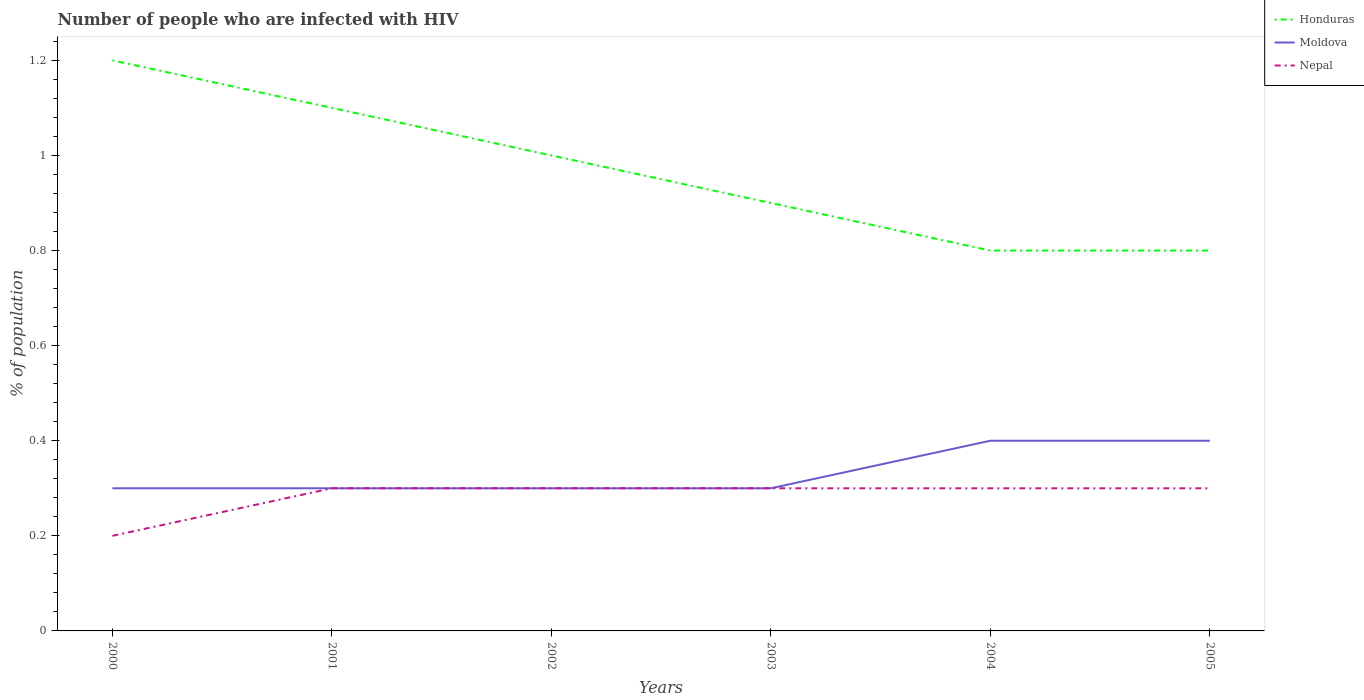How many different coloured lines are there?
Offer a very short reply. 3. Is the number of lines equal to the number of legend labels?
Provide a short and direct response. Yes. Across all years, what is the maximum percentage of HIV infected population in in Moldova?
Make the answer very short. 0.3. In which year was the percentage of HIV infected population in in Moldova maximum?
Your answer should be very brief. 2000. What is the total percentage of HIV infected population in in Moldova in the graph?
Your answer should be compact. -0.1. What is the difference between the highest and the second highest percentage of HIV infected population in in Honduras?
Offer a terse response. 0.4. Is the percentage of HIV infected population in in Honduras strictly greater than the percentage of HIV infected population in in Nepal over the years?
Make the answer very short. No. How many lines are there?
Your answer should be compact. 3. What is the difference between two consecutive major ticks on the Y-axis?
Keep it short and to the point. 0.2. Does the graph contain any zero values?
Your answer should be compact. No. Does the graph contain grids?
Ensure brevity in your answer.  No. Where does the legend appear in the graph?
Your response must be concise. Top right. How many legend labels are there?
Make the answer very short. 3. How are the legend labels stacked?
Your answer should be compact. Vertical. What is the title of the graph?
Keep it short and to the point. Number of people who are infected with HIV. Does "Serbia" appear as one of the legend labels in the graph?
Provide a succinct answer. No. What is the label or title of the Y-axis?
Ensure brevity in your answer.  % of population. What is the % of population of Honduras in 2000?
Make the answer very short. 1.2. What is the % of population in Nepal in 2001?
Keep it short and to the point. 0.3. What is the % of population in Honduras in 2002?
Your answer should be compact. 1. What is the % of population in Moldova in 2002?
Keep it short and to the point. 0.3. What is the % of population in Nepal in 2002?
Offer a terse response. 0.3. What is the % of population of Nepal in 2003?
Offer a terse response. 0.3. What is the % of population of Honduras in 2004?
Give a very brief answer. 0.8. What is the % of population of Nepal in 2004?
Keep it short and to the point. 0.3. What is the % of population of Nepal in 2005?
Ensure brevity in your answer.  0.3. Across all years, what is the maximum % of population of Nepal?
Provide a short and direct response. 0.3. Across all years, what is the minimum % of population in Honduras?
Provide a succinct answer. 0.8. Across all years, what is the minimum % of population of Moldova?
Offer a very short reply. 0.3. What is the total % of population of Honduras in the graph?
Provide a succinct answer. 5.8. What is the total % of population in Nepal in the graph?
Keep it short and to the point. 1.7. What is the difference between the % of population of Honduras in 2000 and that in 2001?
Provide a short and direct response. 0.1. What is the difference between the % of population of Moldova in 2000 and that in 2001?
Keep it short and to the point. 0. What is the difference between the % of population in Nepal in 2000 and that in 2001?
Your answer should be compact. -0.1. What is the difference between the % of population of Moldova in 2000 and that in 2002?
Provide a succinct answer. 0. What is the difference between the % of population of Honduras in 2000 and that in 2003?
Give a very brief answer. 0.3. What is the difference between the % of population in Honduras in 2000 and that in 2004?
Your answer should be very brief. 0.4. What is the difference between the % of population of Nepal in 2000 and that in 2004?
Your response must be concise. -0.1. What is the difference between the % of population in Moldova in 2001 and that in 2002?
Ensure brevity in your answer.  0. What is the difference between the % of population in Nepal in 2001 and that in 2003?
Keep it short and to the point. 0. What is the difference between the % of population in Moldova in 2001 and that in 2004?
Give a very brief answer. -0.1. What is the difference between the % of population in Honduras in 2001 and that in 2005?
Your response must be concise. 0.3. What is the difference between the % of population of Moldova in 2001 and that in 2005?
Give a very brief answer. -0.1. What is the difference between the % of population of Honduras in 2002 and that in 2003?
Keep it short and to the point. 0.1. What is the difference between the % of population of Honduras in 2002 and that in 2004?
Make the answer very short. 0.2. What is the difference between the % of population of Moldova in 2002 and that in 2004?
Offer a terse response. -0.1. What is the difference between the % of population of Moldova in 2002 and that in 2005?
Your answer should be compact. -0.1. What is the difference between the % of population in Nepal in 2002 and that in 2005?
Provide a short and direct response. 0. What is the difference between the % of population of Honduras in 2003 and that in 2004?
Your answer should be compact. 0.1. What is the difference between the % of population of Honduras in 2003 and that in 2005?
Provide a short and direct response. 0.1. What is the difference between the % of population in Moldova in 2003 and that in 2005?
Your response must be concise. -0.1. What is the difference between the % of population of Nepal in 2003 and that in 2005?
Keep it short and to the point. 0. What is the difference between the % of population of Honduras in 2004 and that in 2005?
Make the answer very short. 0. What is the difference between the % of population in Moldova in 2004 and that in 2005?
Offer a very short reply. 0. What is the difference between the % of population of Nepal in 2004 and that in 2005?
Ensure brevity in your answer.  0. What is the difference between the % of population in Honduras in 2000 and the % of population in Moldova in 2001?
Your answer should be compact. 0.9. What is the difference between the % of population in Honduras in 2000 and the % of population in Nepal in 2001?
Your response must be concise. 0.9. What is the difference between the % of population in Moldova in 2000 and the % of population in Nepal in 2001?
Your answer should be very brief. 0. What is the difference between the % of population of Honduras in 2000 and the % of population of Nepal in 2002?
Your answer should be compact. 0.9. What is the difference between the % of population of Moldova in 2000 and the % of population of Nepal in 2002?
Make the answer very short. 0. What is the difference between the % of population of Moldova in 2000 and the % of population of Nepal in 2003?
Provide a short and direct response. 0. What is the difference between the % of population in Honduras in 2000 and the % of population in Moldova in 2004?
Your response must be concise. 0.8. What is the difference between the % of population of Moldova in 2000 and the % of population of Nepal in 2004?
Give a very brief answer. 0. What is the difference between the % of population of Honduras in 2000 and the % of population of Moldova in 2005?
Offer a terse response. 0.8. What is the difference between the % of population of Moldova in 2000 and the % of population of Nepal in 2005?
Offer a very short reply. 0. What is the difference between the % of population of Honduras in 2001 and the % of population of Nepal in 2002?
Give a very brief answer. 0.8. What is the difference between the % of population in Honduras in 2001 and the % of population in Moldova in 2003?
Give a very brief answer. 0.8. What is the difference between the % of population of Honduras in 2001 and the % of population of Nepal in 2003?
Give a very brief answer. 0.8. What is the difference between the % of population of Moldova in 2001 and the % of population of Nepal in 2003?
Provide a short and direct response. 0. What is the difference between the % of population of Honduras in 2001 and the % of population of Moldova in 2004?
Make the answer very short. 0.7. What is the difference between the % of population in Honduras in 2001 and the % of population in Moldova in 2005?
Your response must be concise. 0.7. What is the difference between the % of population of Honduras in 2001 and the % of population of Nepal in 2005?
Your answer should be compact. 0.8. What is the difference between the % of population in Moldova in 2001 and the % of population in Nepal in 2005?
Ensure brevity in your answer.  0. What is the difference between the % of population of Moldova in 2002 and the % of population of Nepal in 2003?
Provide a short and direct response. 0. What is the difference between the % of population in Honduras in 2002 and the % of population in Nepal in 2004?
Provide a succinct answer. 0.7. What is the difference between the % of population in Moldova in 2002 and the % of population in Nepal in 2004?
Keep it short and to the point. 0. What is the difference between the % of population in Moldova in 2002 and the % of population in Nepal in 2005?
Make the answer very short. 0. What is the difference between the % of population of Honduras in 2003 and the % of population of Nepal in 2004?
Provide a short and direct response. 0.6. What is the difference between the % of population in Moldova in 2003 and the % of population in Nepal in 2004?
Your answer should be very brief. 0. What is the difference between the % of population in Moldova in 2003 and the % of population in Nepal in 2005?
Offer a terse response. 0. What is the difference between the % of population of Honduras in 2004 and the % of population of Moldova in 2005?
Your answer should be compact. 0.4. What is the difference between the % of population in Moldova in 2004 and the % of population in Nepal in 2005?
Make the answer very short. 0.1. What is the average % of population in Honduras per year?
Ensure brevity in your answer.  0.97. What is the average % of population of Moldova per year?
Your answer should be very brief. 0.33. What is the average % of population of Nepal per year?
Keep it short and to the point. 0.28. In the year 2000, what is the difference between the % of population in Honduras and % of population in Moldova?
Give a very brief answer. 0.9. In the year 2000, what is the difference between the % of population of Honduras and % of population of Nepal?
Your response must be concise. 1. In the year 2001, what is the difference between the % of population of Honduras and % of population of Moldova?
Keep it short and to the point. 0.8. In the year 2001, what is the difference between the % of population in Moldova and % of population in Nepal?
Offer a very short reply. 0. In the year 2003, what is the difference between the % of population of Honduras and % of population of Moldova?
Offer a terse response. 0.6. In the year 2004, what is the difference between the % of population of Moldova and % of population of Nepal?
Make the answer very short. 0.1. In the year 2005, what is the difference between the % of population of Honduras and % of population of Nepal?
Offer a very short reply. 0.5. In the year 2005, what is the difference between the % of population in Moldova and % of population in Nepal?
Ensure brevity in your answer.  0.1. What is the ratio of the % of population of Moldova in 2000 to that in 2001?
Make the answer very short. 1. What is the ratio of the % of population of Nepal in 2000 to that in 2001?
Provide a succinct answer. 0.67. What is the ratio of the % of population in Honduras in 2000 to that in 2002?
Offer a terse response. 1.2. What is the ratio of the % of population in Nepal in 2000 to that in 2002?
Offer a very short reply. 0.67. What is the ratio of the % of population of Moldova in 2000 to that in 2004?
Provide a succinct answer. 0.75. What is the ratio of the % of population of Moldova in 2000 to that in 2005?
Offer a very short reply. 0.75. What is the ratio of the % of population of Nepal in 2000 to that in 2005?
Your answer should be compact. 0.67. What is the ratio of the % of population in Honduras in 2001 to that in 2003?
Provide a succinct answer. 1.22. What is the ratio of the % of population in Honduras in 2001 to that in 2004?
Make the answer very short. 1.38. What is the ratio of the % of population in Nepal in 2001 to that in 2004?
Give a very brief answer. 1. What is the ratio of the % of population of Honduras in 2001 to that in 2005?
Your response must be concise. 1.38. What is the ratio of the % of population in Nepal in 2001 to that in 2005?
Offer a very short reply. 1. What is the ratio of the % of population in Moldova in 2002 to that in 2004?
Provide a short and direct response. 0.75. What is the ratio of the % of population of Nepal in 2002 to that in 2004?
Provide a short and direct response. 1. What is the ratio of the % of population in Honduras in 2003 to that in 2004?
Your answer should be compact. 1.12. What is the ratio of the % of population in Nepal in 2003 to that in 2004?
Keep it short and to the point. 1. What is the ratio of the % of population of Honduras in 2003 to that in 2005?
Your response must be concise. 1.12. What is the ratio of the % of population in Nepal in 2003 to that in 2005?
Your answer should be compact. 1. What is the ratio of the % of population in Honduras in 2004 to that in 2005?
Provide a short and direct response. 1. What is the difference between the highest and the second highest % of population of Honduras?
Provide a short and direct response. 0.1. What is the difference between the highest and the second highest % of population of Nepal?
Keep it short and to the point. 0. 